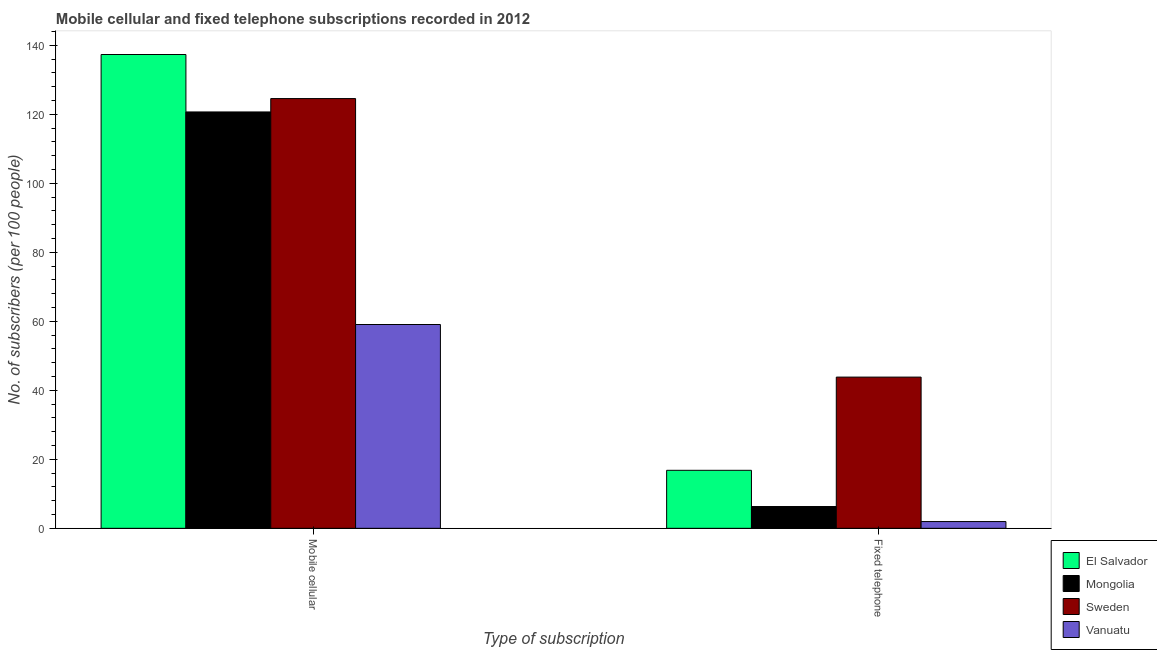How many groups of bars are there?
Provide a succinct answer. 2. Are the number of bars on each tick of the X-axis equal?
Make the answer very short. Yes. How many bars are there on the 2nd tick from the left?
Provide a succinct answer. 4. How many bars are there on the 2nd tick from the right?
Ensure brevity in your answer.  4. What is the label of the 1st group of bars from the left?
Provide a succinct answer. Mobile cellular. What is the number of fixed telephone subscribers in Sweden?
Offer a very short reply. 43.83. Across all countries, what is the maximum number of mobile cellular subscribers?
Provide a short and direct response. 137.34. Across all countries, what is the minimum number of fixed telephone subscribers?
Your answer should be very brief. 1.96. In which country was the number of fixed telephone subscribers maximum?
Provide a short and direct response. Sweden. In which country was the number of mobile cellular subscribers minimum?
Your answer should be very brief. Vanuatu. What is the total number of mobile cellular subscribers in the graph?
Your response must be concise. 441.69. What is the difference between the number of fixed telephone subscribers in Mongolia and that in Sweden?
Give a very brief answer. -37.51. What is the difference between the number of fixed telephone subscribers in Vanuatu and the number of mobile cellular subscribers in Sweden?
Provide a short and direct response. -122.61. What is the average number of mobile cellular subscribers per country?
Provide a succinct answer. 110.42. What is the difference between the number of fixed telephone subscribers and number of mobile cellular subscribers in Mongolia?
Offer a terse response. -114.38. What is the ratio of the number of mobile cellular subscribers in Mongolia to that in Sweden?
Give a very brief answer. 0.97. Is the number of fixed telephone subscribers in El Salvador less than that in Sweden?
Make the answer very short. Yes. What does the 2nd bar from the right in Mobile cellular represents?
Give a very brief answer. Sweden. Are the values on the major ticks of Y-axis written in scientific E-notation?
Offer a very short reply. No. Does the graph contain grids?
Make the answer very short. No. What is the title of the graph?
Provide a short and direct response. Mobile cellular and fixed telephone subscriptions recorded in 2012. What is the label or title of the X-axis?
Your answer should be very brief. Type of subscription. What is the label or title of the Y-axis?
Provide a succinct answer. No. of subscribers (per 100 people). What is the No. of subscribers (per 100 people) of El Salvador in Mobile cellular?
Give a very brief answer. 137.34. What is the No. of subscribers (per 100 people) of Mongolia in Mobile cellular?
Offer a very short reply. 120.69. What is the No. of subscribers (per 100 people) of Sweden in Mobile cellular?
Keep it short and to the point. 124.57. What is the No. of subscribers (per 100 people) in Vanuatu in Mobile cellular?
Make the answer very short. 59.08. What is the No. of subscribers (per 100 people) of El Salvador in Fixed telephone?
Provide a short and direct response. 16.82. What is the No. of subscribers (per 100 people) in Mongolia in Fixed telephone?
Offer a terse response. 6.32. What is the No. of subscribers (per 100 people) of Sweden in Fixed telephone?
Keep it short and to the point. 43.83. What is the No. of subscribers (per 100 people) of Vanuatu in Fixed telephone?
Give a very brief answer. 1.96. Across all Type of subscription, what is the maximum No. of subscribers (per 100 people) of El Salvador?
Ensure brevity in your answer.  137.34. Across all Type of subscription, what is the maximum No. of subscribers (per 100 people) in Mongolia?
Offer a very short reply. 120.69. Across all Type of subscription, what is the maximum No. of subscribers (per 100 people) of Sweden?
Your response must be concise. 124.57. Across all Type of subscription, what is the maximum No. of subscribers (per 100 people) of Vanuatu?
Give a very brief answer. 59.08. Across all Type of subscription, what is the minimum No. of subscribers (per 100 people) of El Salvador?
Your answer should be compact. 16.82. Across all Type of subscription, what is the minimum No. of subscribers (per 100 people) of Mongolia?
Make the answer very short. 6.32. Across all Type of subscription, what is the minimum No. of subscribers (per 100 people) in Sweden?
Make the answer very short. 43.83. Across all Type of subscription, what is the minimum No. of subscribers (per 100 people) in Vanuatu?
Your response must be concise. 1.96. What is the total No. of subscribers (per 100 people) in El Salvador in the graph?
Offer a very short reply. 154.16. What is the total No. of subscribers (per 100 people) in Mongolia in the graph?
Offer a terse response. 127.01. What is the total No. of subscribers (per 100 people) in Sweden in the graph?
Your response must be concise. 168.41. What is the total No. of subscribers (per 100 people) in Vanuatu in the graph?
Your answer should be very brief. 61.04. What is the difference between the No. of subscribers (per 100 people) of El Salvador in Mobile cellular and that in Fixed telephone?
Your answer should be compact. 120.53. What is the difference between the No. of subscribers (per 100 people) of Mongolia in Mobile cellular and that in Fixed telephone?
Make the answer very short. 114.38. What is the difference between the No. of subscribers (per 100 people) in Sweden in Mobile cellular and that in Fixed telephone?
Keep it short and to the point. 80.74. What is the difference between the No. of subscribers (per 100 people) in Vanuatu in Mobile cellular and that in Fixed telephone?
Provide a short and direct response. 57.12. What is the difference between the No. of subscribers (per 100 people) in El Salvador in Mobile cellular and the No. of subscribers (per 100 people) in Mongolia in Fixed telephone?
Your response must be concise. 131.02. What is the difference between the No. of subscribers (per 100 people) in El Salvador in Mobile cellular and the No. of subscribers (per 100 people) in Sweden in Fixed telephone?
Keep it short and to the point. 93.51. What is the difference between the No. of subscribers (per 100 people) of El Salvador in Mobile cellular and the No. of subscribers (per 100 people) of Vanuatu in Fixed telephone?
Offer a terse response. 135.38. What is the difference between the No. of subscribers (per 100 people) of Mongolia in Mobile cellular and the No. of subscribers (per 100 people) of Sweden in Fixed telephone?
Your response must be concise. 76.86. What is the difference between the No. of subscribers (per 100 people) in Mongolia in Mobile cellular and the No. of subscribers (per 100 people) in Vanuatu in Fixed telephone?
Your answer should be compact. 118.73. What is the difference between the No. of subscribers (per 100 people) of Sweden in Mobile cellular and the No. of subscribers (per 100 people) of Vanuatu in Fixed telephone?
Provide a succinct answer. 122.61. What is the average No. of subscribers (per 100 people) of El Salvador per Type of subscription?
Offer a very short reply. 77.08. What is the average No. of subscribers (per 100 people) of Mongolia per Type of subscription?
Provide a succinct answer. 63.51. What is the average No. of subscribers (per 100 people) in Sweden per Type of subscription?
Keep it short and to the point. 84.2. What is the average No. of subscribers (per 100 people) of Vanuatu per Type of subscription?
Keep it short and to the point. 30.52. What is the difference between the No. of subscribers (per 100 people) of El Salvador and No. of subscribers (per 100 people) of Mongolia in Mobile cellular?
Offer a terse response. 16.65. What is the difference between the No. of subscribers (per 100 people) in El Salvador and No. of subscribers (per 100 people) in Sweden in Mobile cellular?
Your response must be concise. 12.77. What is the difference between the No. of subscribers (per 100 people) in El Salvador and No. of subscribers (per 100 people) in Vanuatu in Mobile cellular?
Your answer should be very brief. 78.26. What is the difference between the No. of subscribers (per 100 people) of Mongolia and No. of subscribers (per 100 people) of Sweden in Mobile cellular?
Offer a terse response. -3.88. What is the difference between the No. of subscribers (per 100 people) in Mongolia and No. of subscribers (per 100 people) in Vanuatu in Mobile cellular?
Give a very brief answer. 61.61. What is the difference between the No. of subscribers (per 100 people) of Sweden and No. of subscribers (per 100 people) of Vanuatu in Mobile cellular?
Offer a terse response. 65.49. What is the difference between the No. of subscribers (per 100 people) in El Salvador and No. of subscribers (per 100 people) in Mongolia in Fixed telephone?
Offer a very short reply. 10.5. What is the difference between the No. of subscribers (per 100 people) in El Salvador and No. of subscribers (per 100 people) in Sweden in Fixed telephone?
Ensure brevity in your answer.  -27.02. What is the difference between the No. of subscribers (per 100 people) of El Salvador and No. of subscribers (per 100 people) of Vanuatu in Fixed telephone?
Offer a terse response. 14.86. What is the difference between the No. of subscribers (per 100 people) in Mongolia and No. of subscribers (per 100 people) in Sweden in Fixed telephone?
Offer a terse response. -37.51. What is the difference between the No. of subscribers (per 100 people) of Mongolia and No. of subscribers (per 100 people) of Vanuatu in Fixed telephone?
Offer a very short reply. 4.36. What is the difference between the No. of subscribers (per 100 people) of Sweden and No. of subscribers (per 100 people) of Vanuatu in Fixed telephone?
Your answer should be compact. 41.87. What is the ratio of the No. of subscribers (per 100 people) in El Salvador in Mobile cellular to that in Fixed telephone?
Keep it short and to the point. 8.17. What is the ratio of the No. of subscribers (per 100 people) of Mongolia in Mobile cellular to that in Fixed telephone?
Give a very brief answer. 19.1. What is the ratio of the No. of subscribers (per 100 people) in Sweden in Mobile cellular to that in Fixed telephone?
Give a very brief answer. 2.84. What is the ratio of the No. of subscribers (per 100 people) in Vanuatu in Mobile cellular to that in Fixed telephone?
Your answer should be compact. 30.13. What is the difference between the highest and the second highest No. of subscribers (per 100 people) of El Salvador?
Make the answer very short. 120.53. What is the difference between the highest and the second highest No. of subscribers (per 100 people) of Mongolia?
Make the answer very short. 114.38. What is the difference between the highest and the second highest No. of subscribers (per 100 people) in Sweden?
Keep it short and to the point. 80.74. What is the difference between the highest and the second highest No. of subscribers (per 100 people) of Vanuatu?
Provide a short and direct response. 57.12. What is the difference between the highest and the lowest No. of subscribers (per 100 people) of El Salvador?
Offer a terse response. 120.53. What is the difference between the highest and the lowest No. of subscribers (per 100 people) of Mongolia?
Offer a very short reply. 114.38. What is the difference between the highest and the lowest No. of subscribers (per 100 people) in Sweden?
Provide a succinct answer. 80.74. What is the difference between the highest and the lowest No. of subscribers (per 100 people) in Vanuatu?
Your response must be concise. 57.12. 